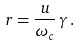<formula> <loc_0><loc_0><loc_500><loc_500>r = \frac { u } { \omega _ { c } } \, \gamma \, .</formula> 